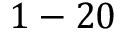Convert formula to latex. <formula><loc_0><loc_0><loc_500><loc_500>1 - 2 0</formula> 